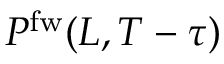<formula> <loc_0><loc_0><loc_500><loc_500>P ^ { f w } ( L , T - \tau )</formula> 